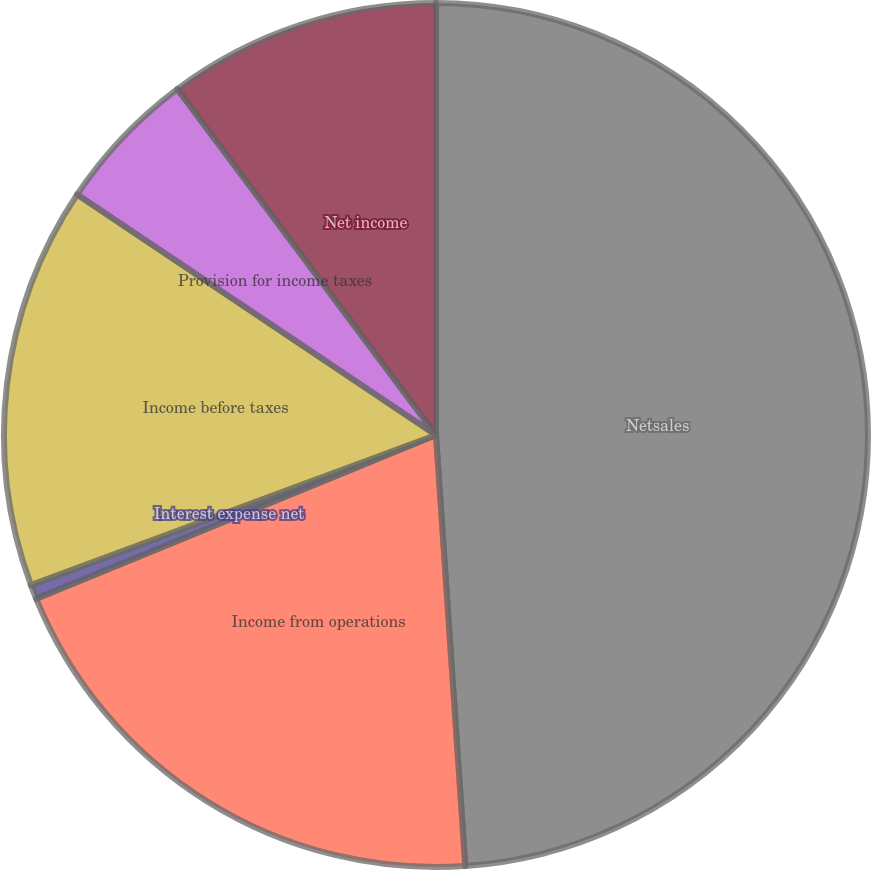<chart> <loc_0><loc_0><loc_500><loc_500><pie_chart><fcel>Netsales<fcel>Income from operations<fcel>Interest expense net<fcel>Income before taxes<fcel>Provision for income taxes<fcel>Net income<nl><fcel>48.92%<fcel>19.89%<fcel>0.54%<fcel>15.05%<fcel>5.38%<fcel>10.22%<nl></chart> 